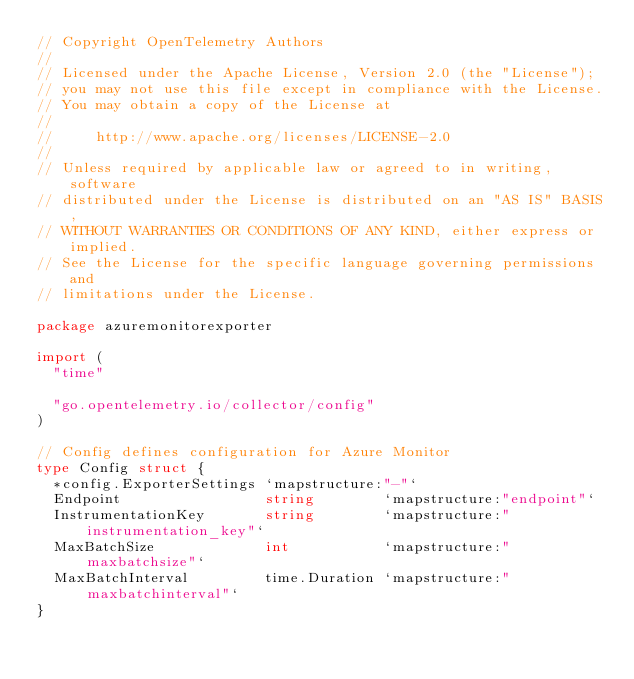<code> <loc_0><loc_0><loc_500><loc_500><_Go_>// Copyright OpenTelemetry Authors
//
// Licensed under the Apache License, Version 2.0 (the "License");
// you may not use this file except in compliance with the License.
// You may obtain a copy of the License at
//
//     http://www.apache.org/licenses/LICENSE-2.0
//
// Unless required by applicable law or agreed to in writing, software
// distributed under the License is distributed on an "AS IS" BASIS,
// WITHOUT WARRANTIES OR CONDITIONS OF ANY KIND, either express or implied.
// See the License for the specific language governing permissions and
// limitations under the License.

package azuremonitorexporter

import (
	"time"

	"go.opentelemetry.io/collector/config"
)

// Config defines configuration for Azure Monitor
type Config struct {
	*config.ExporterSettings `mapstructure:"-"`
	Endpoint                 string        `mapstructure:"endpoint"`
	InstrumentationKey       string        `mapstructure:"instrumentation_key"`
	MaxBatchSize             int           `mapstructure:"maxbatchsize"`
	MaxBatchInterval         time.Duration `mapstructure:"maxbatchinterval"`
}
</code> 